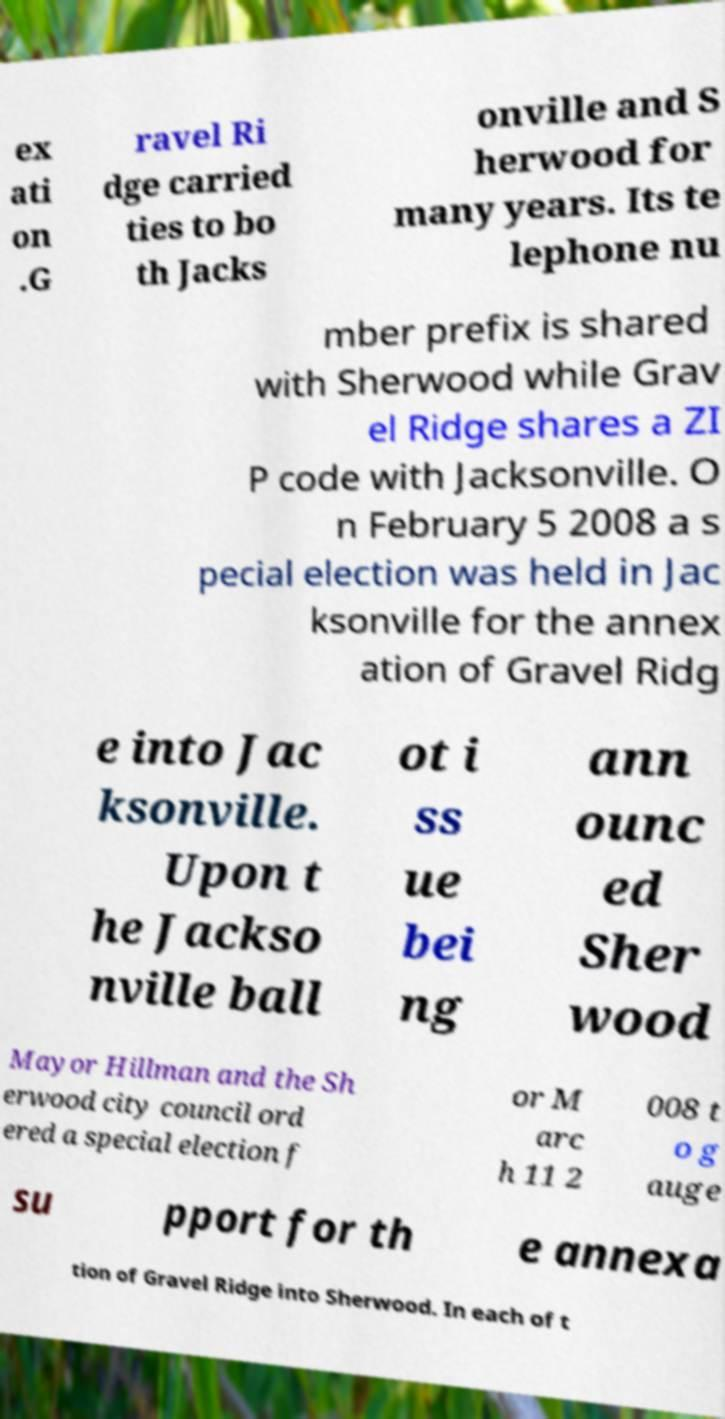Could you extract and type out the text from this image? ex ati on .G ravel Ri dge carried ties to bo th Jacks onville and S herwood for many years. Its te lephone nu mber prefix is shared with Sherwood while Grav el Ridge shares a ZI P code with Jacksonville. O n February 5 2008 a s pecial election was held in Jac ksonville for the annex ation of Gravel Ridg e into Jac ksonville. Upon t he Jackso nville ball ot i ss ue bei ng ann ounc ed Sher wood Mayor Hillman and the Sh erwood city council ord ered a special election f or M arc h 11 2 008 t o g auge su pport for th e annexa tion of Gravel Ridge into Sherwood. In each of t 